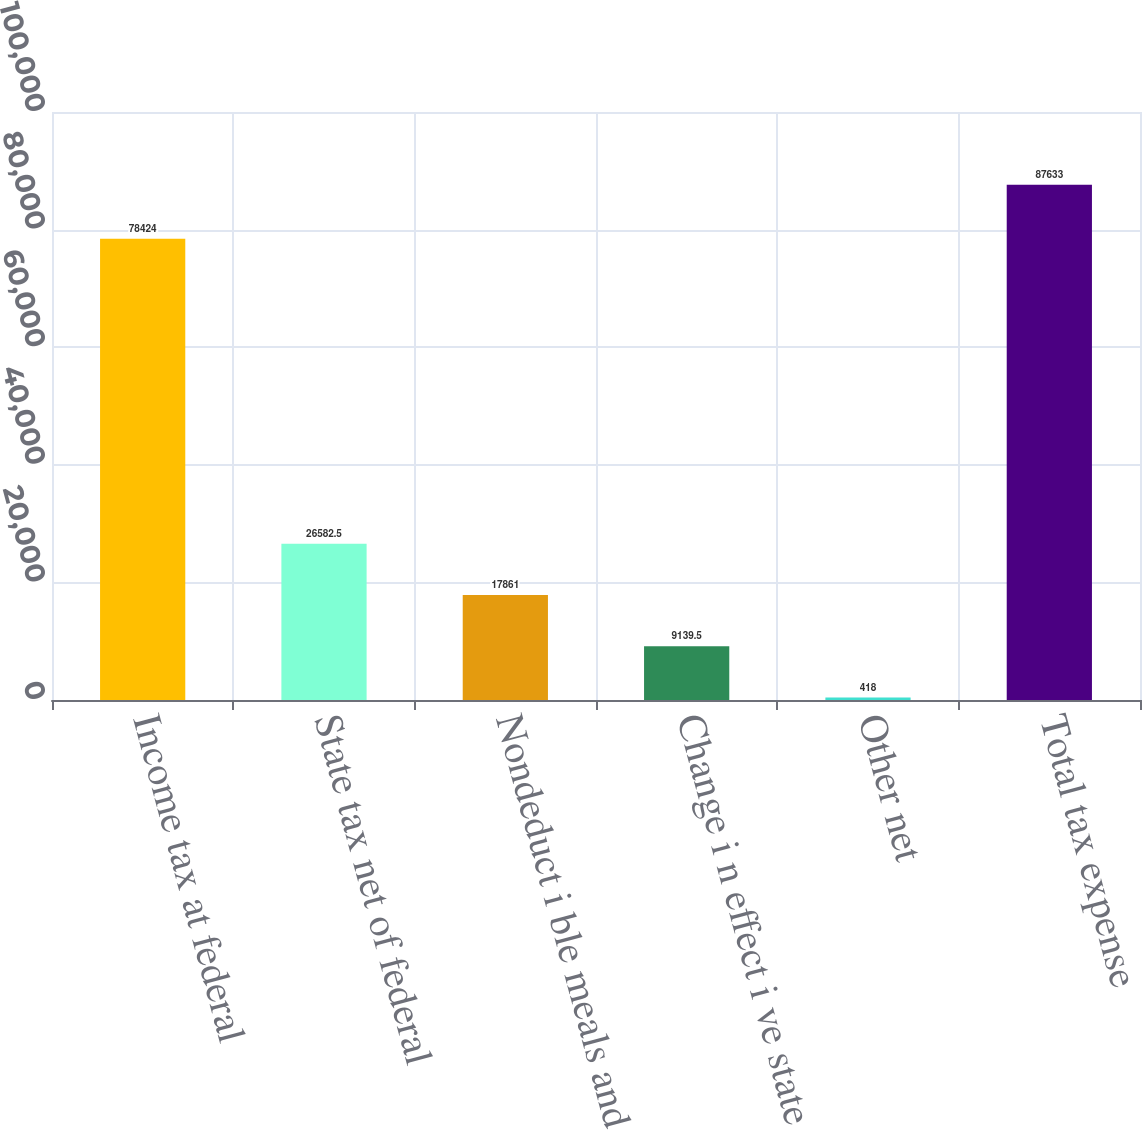<chart> <loc_0><loc_0><loc_500><loc_500><bar_chart><fcel>Income tax at federal<fcel>State tax net of federal<fcel>Nondeduct i ble meals and<fcel>Change i n effect i ve state<fcel>Other net<fcel>Total tax expense<nl><fcel>78424<fcel>26582.5<fcel>17861<fcel>9139.5<fcel>418<fcel>87633<nl></chart> 